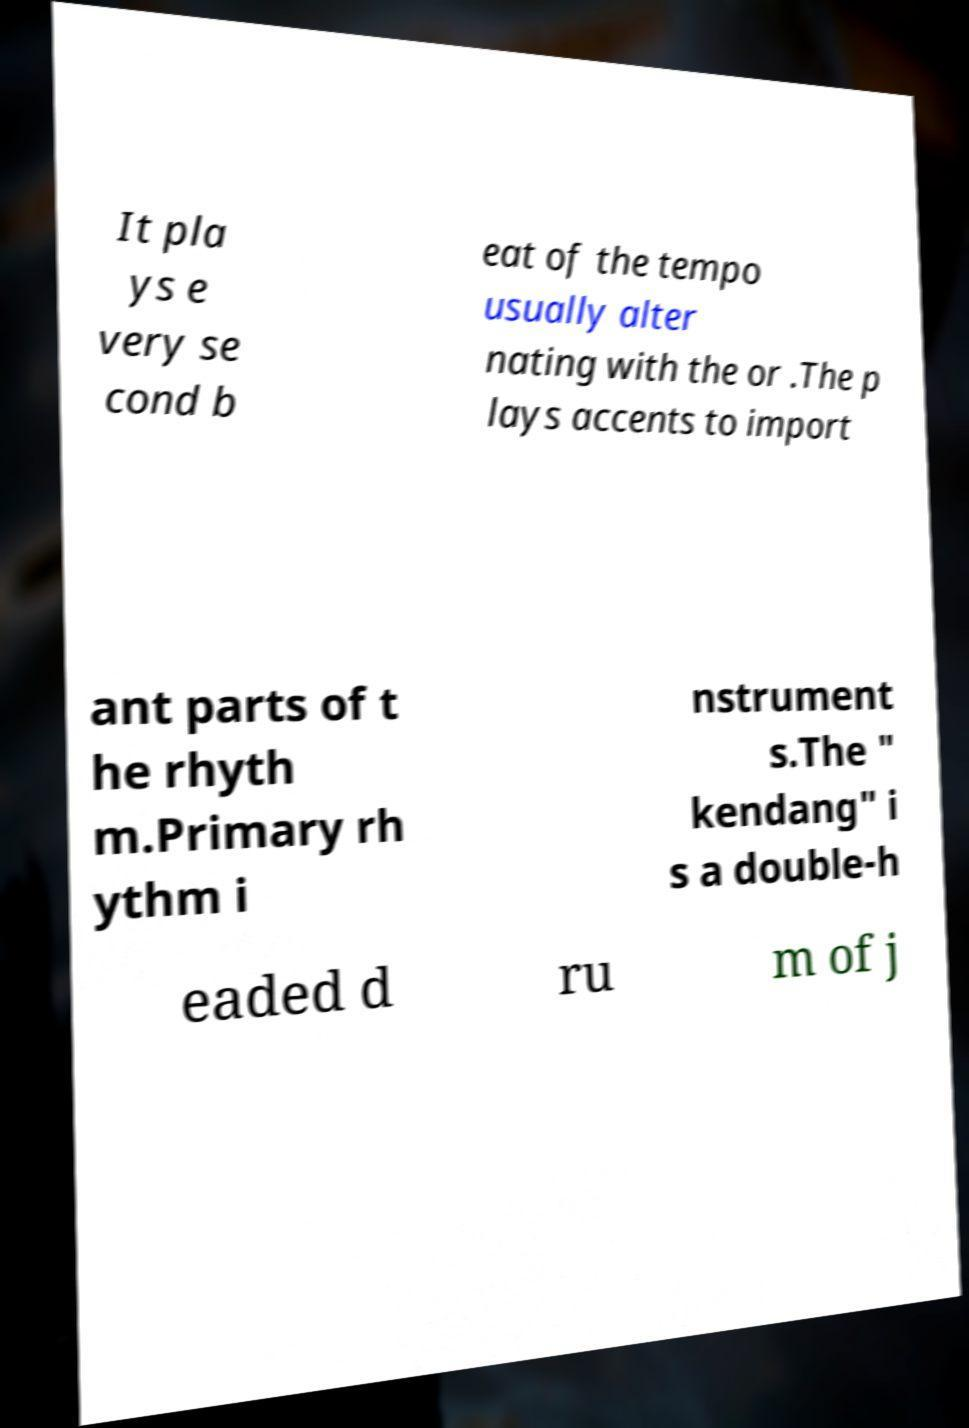Can you read and provide the text displayed in the image?This photo seems to have some interesting text. Can you extract and type it out for me? It pla ys e very se cond b eat of the tempo usually alter nating with the or .The p lays accents to import ant parts of t he rhyth m.Primary rh ythm i nstrument s.The " kendang" i s a double-h eaded d ru m of j 